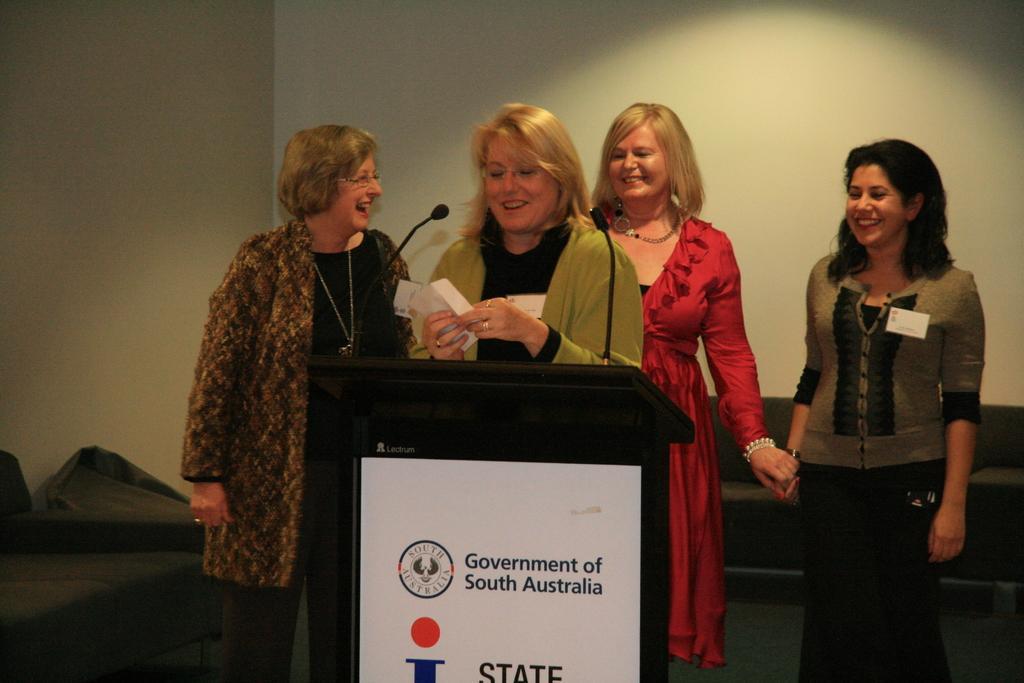Could you give a brief overview of what you see in this image? There are four women standing and smiling. This is the podium with the mike. I can see a board, which is attached to the podium. I can see the couches. This is the wall. 